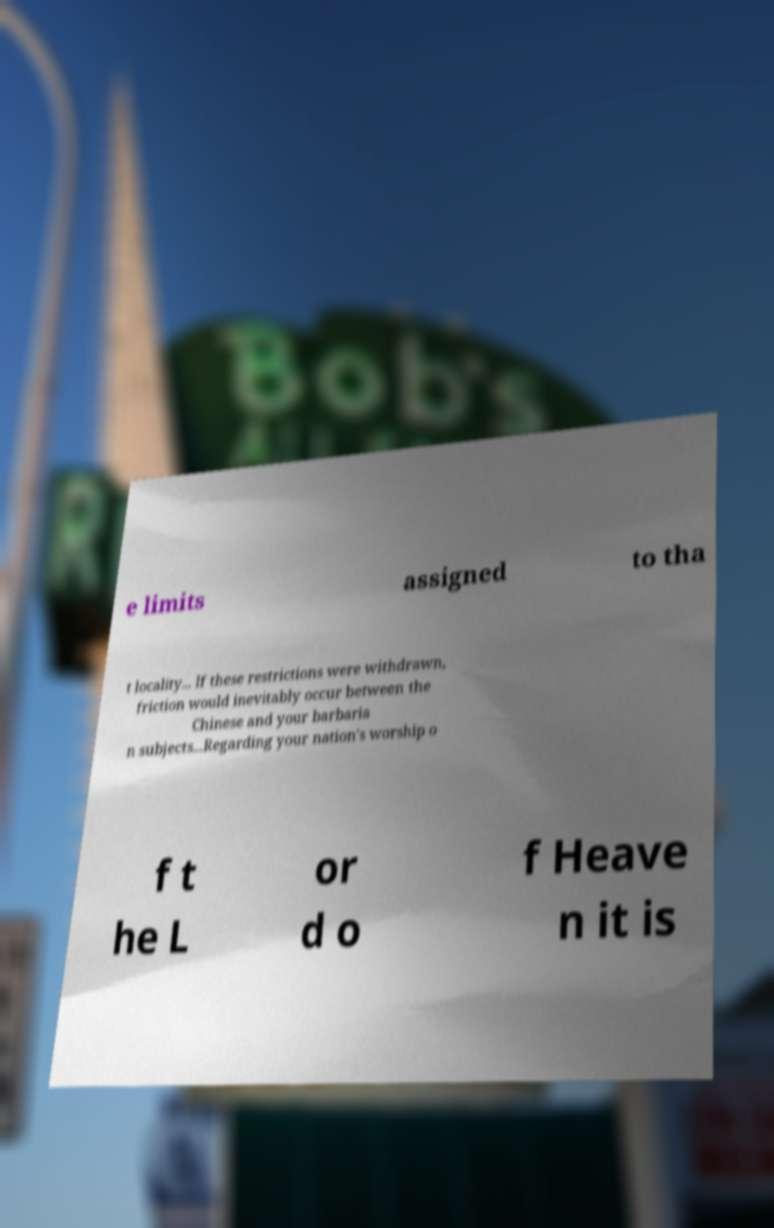Please read and relay the text visible in this image. What does it say? e limits assigned to tha t locality... If these restrictions were withdrawn, friction would inevitably occur between the Chinese and your barbaria n subjects...Regarding your nation's worship o f t he L or d o f Heave n it is 